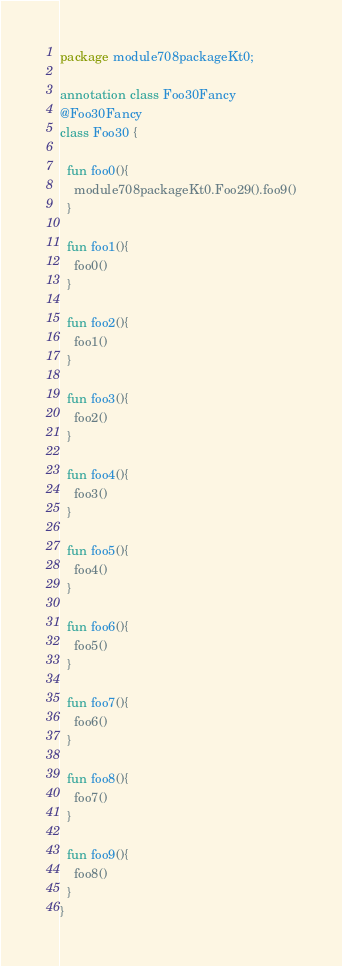Convert code to text. <code><loc_0><loc_0><loc_500><loc_500><_Kotlin_>package module708packageKt0;

annotation class Foo30Fancy
@Foo30Fancy
class Foo30 {

  fun foo0(){
    module708packageKt0.Foo29().foo9()
  }

  fun foo1(){
    foo0()
  }

  fun foo2(){
    foo1()
  }

  fun foo3(){
    foo2()
  }

  fun foo4(){
    foo3()
  }

  fun foo5(){
    foo4()
  }

  fun foo6(){
    foo5()
  }

  fun foo7(){
    foo6()
  }

  fun foo8(){
    foo7()
  }

  fun foo9(){
    foo8()
  }
}</code> 